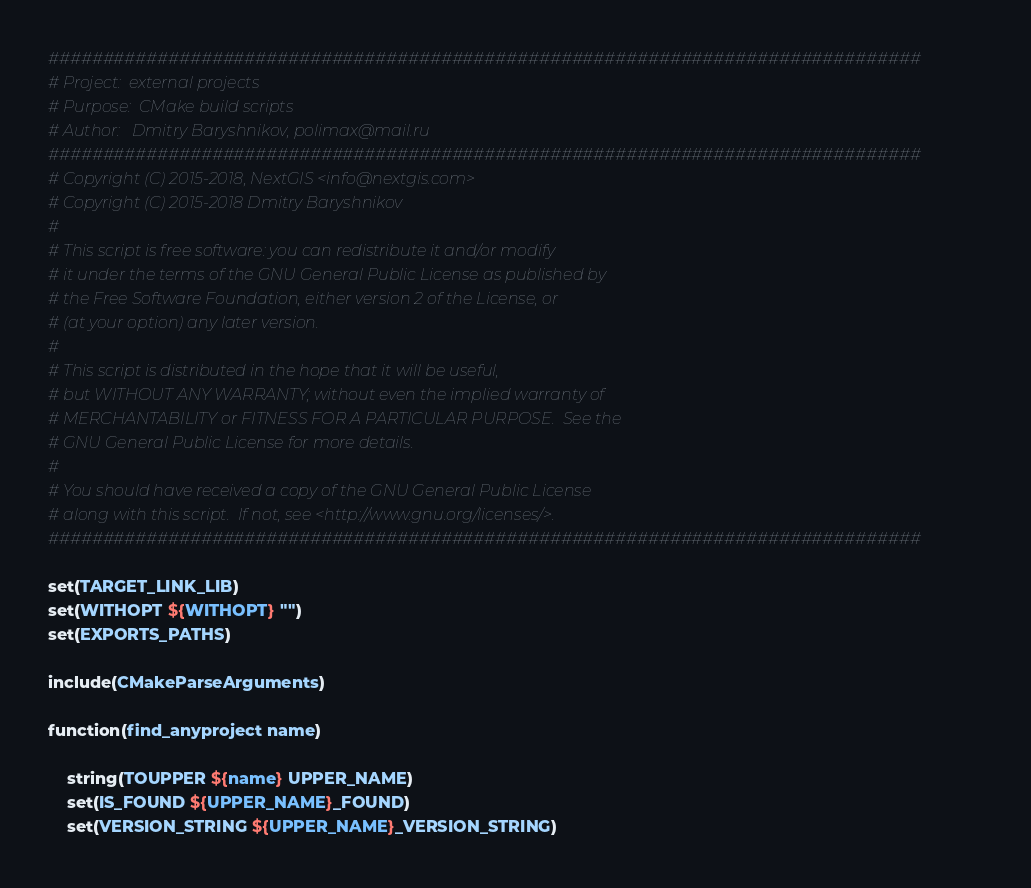Convert code to text. <code><loc_0><loc_0><loc_500><loc_500><_CMake_>################################################################################
# Project:  external projects
# Purpose:  CMake build scripts
# Author:   Dmitry Baryshnikov, polimax@mail.ru
################################################################################
# Copyright (C) 2015-2018, NextGIS <info@nextgis.com>
# Copyright (C) 2015-2018 Dmitry Baryshnikov
#
# This script is free software: you can redistribute it and/or modify
# it under the terms of the GNU General Public License as published by
# the Free Software Foundation, either version 2 of the License, or
# (at your option) any later version.
#
# This script is distributed in the hope that it will be useful,
# but WITHOUT ANY WARRANTY; without even the implied warranty of
# MERCHANTABILITY or FITNESS FOR A PARTICULAR PURPOSE.  See the
# GNU General Public License for more details.
#
# You should have received a copy of the GNU General Public License
# along with this script.  If not, see <http://www.gnu.org/licenses/>.
################################################################################

set(TARGET_LINK_LIB)
set(WITHOPT ${WITHOPT} "")
set(EXPORTS_PATHS)

include(CMakeParseArguments)

function(find_anyproject name)

    string(TOUPPER ${name} UPPER_NAME)
    set(IS_FOUND ${UPPER_NAME}_FOUND)
    set(VERSION_STRING ${UPPER_NAME}_VERSION_STRING)</code> 